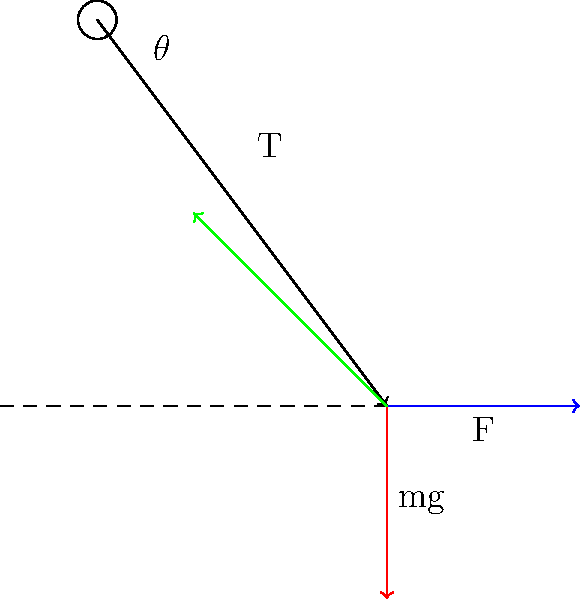In the context of enhancing museum exhibits on classical mechanics, consider a simple pendulum in motion. The diagram shows the forces acting on the pendulum bob at a specific point in its swing. Identify the force represented by the green vector and explain its significance in the pendulum's motion. To answer this question, let's analyze the forces acting on the pendulum bob:

1. Red vector (pointing downward): This represents the gravitational force ($mg$), always acting vertically downward.

2. Blue vector (pointing horizontally): This represents the centripetal force ($F$), which is responsible for the circular motion of the pendulum.

3. Green vector (pointing diagonally upward): This represents the tension force ($T$) in the string or rod of the pendulum.

The green vector (tension force) is significant for the following reasons:

a) It maintains the pendulum's constraint, keeping the bob at a fixed distance from the pivot point.

b) The vertical component of the tension force opposes gravity, preventing the bob from falling straight down.

c) The horizontal component of the tension force provides the centripetal force necessary for circular motion.

d) The tension force, along with gravity, is responsible for the oscillatory motion of the pendulum.

In the context of the pendulum's motion:

$$T \cos\theta = mg - ma_r$$
$$T \sin\theta = ma_t$$

Where $\theta$ is the angle of displacement, $a_r$ is the radial acceleration, and $a_t$ is the tangential acceleration.

Understanding this force is crucial for explaining the pendulum's behavior to museum visitors and can be used in interactive exhibits demonstrating principles of classical mechanics.
Answer: Tension force (T) 